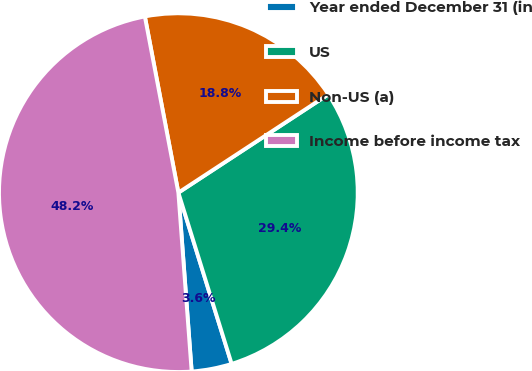<chart> <loc_0><loc_0><loc_500><loc_500><pie_chart><fcel>Year ended December 31 (in<fcel>US<fcel>Non-US (a)<fcel>Income before income tax<nl><fcel>3.62%<fcel>29.43%<fcel>18.76%<fcel>48.19%<nl></chart> 